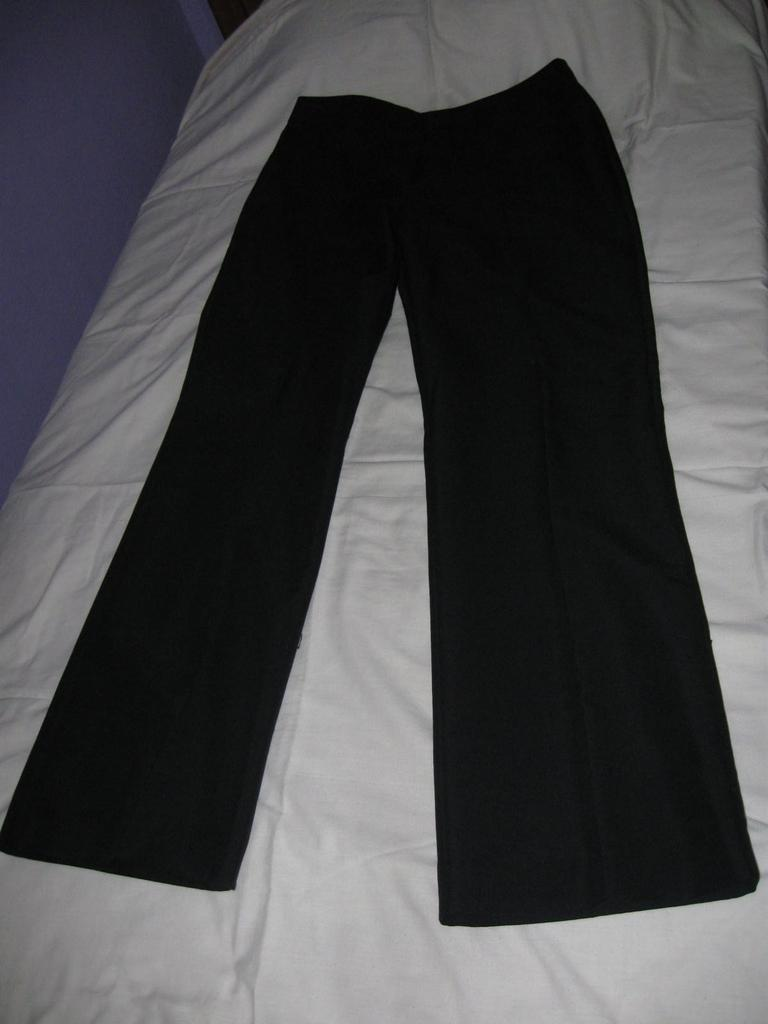What color is the cloth that is on the bed in the image? There is a white colored cloth on the bed. Is there another cloth on top of the white cloth? Yes, there is a black colored cloth on the white cloth. What color is the wall on the left side of the image? There is a purple colored wall on the left side of the image. What type of cloud can be seen in the image? There are no clouds present in the image; it features a bed with white and black colored cloths and a purple colored wall. 